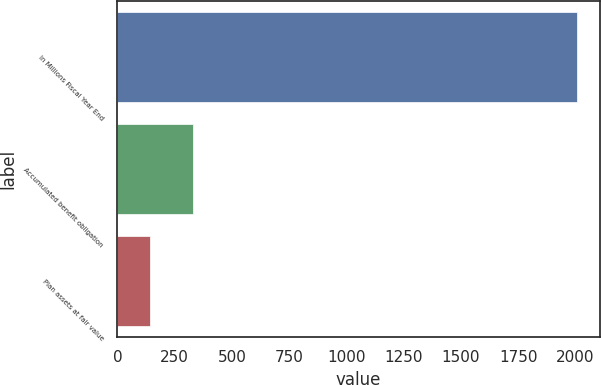Convert chart to OTSL. <chart><loc_0><loc_0><loc_500><loc_500><bar_chart><fcel>In Millions Fiscal Year End<fcel>Accumulated benefit obligation<fcel>Plan assets at fair value<nl><fcel>2005<fcel>330.1<fcel>144<nl></chart> 